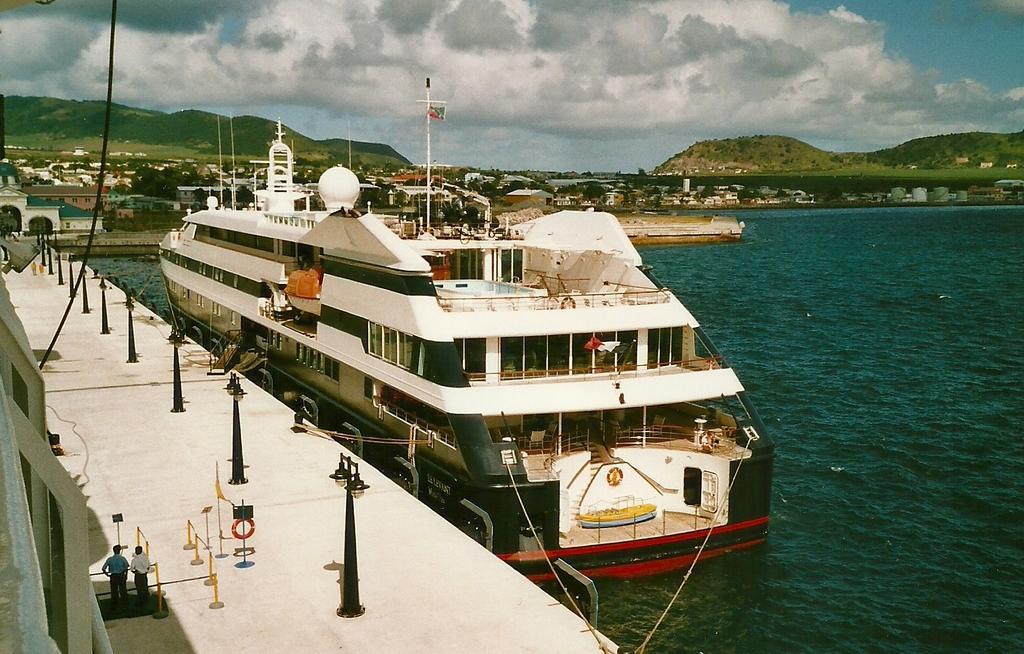Can you describe this image briefly? In this image I can see few trees,few buildings,light poles,poles,boat,few people,water and mountains. The sky is in white and blue color. 